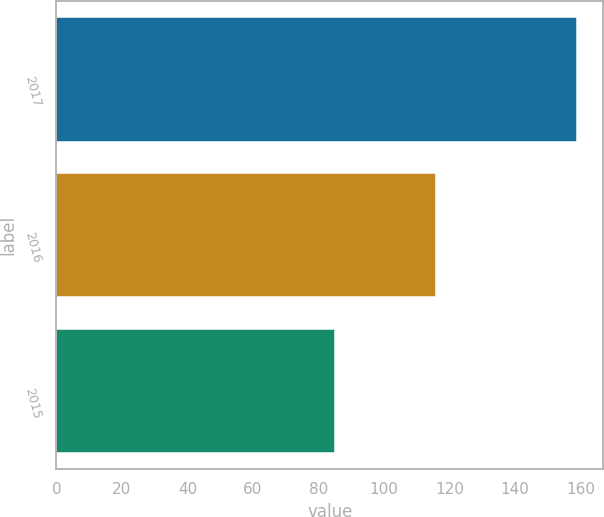Convert chart to OTSL. <chart><loc_0><loc_0><loc_500><loc_500><bar_chart><fcel>2017<fcel>2016<fcel>2015<nl><fcel>159<fcel>116<fcel>85<nl></chart> 